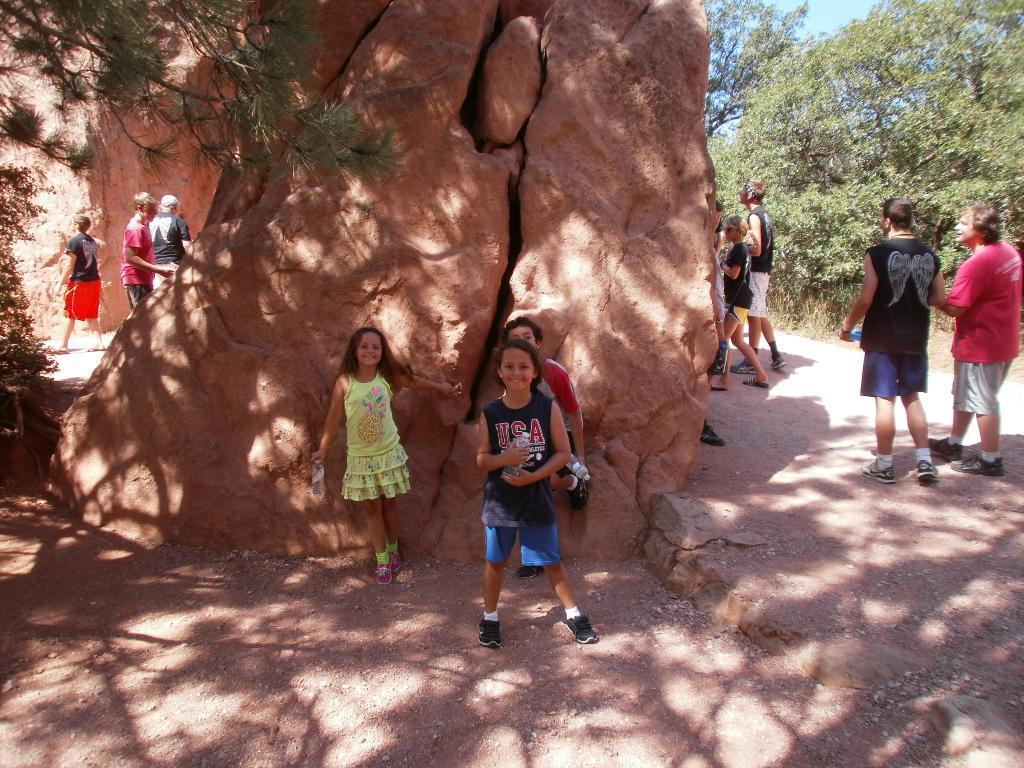In one or two sentences, can you explain what this image depicts? In this picture we can see some people are walking and three kids are standing, there is a rock in the middle, on the right side and left side there are trees, we can see the sky at the right top of the picture. 